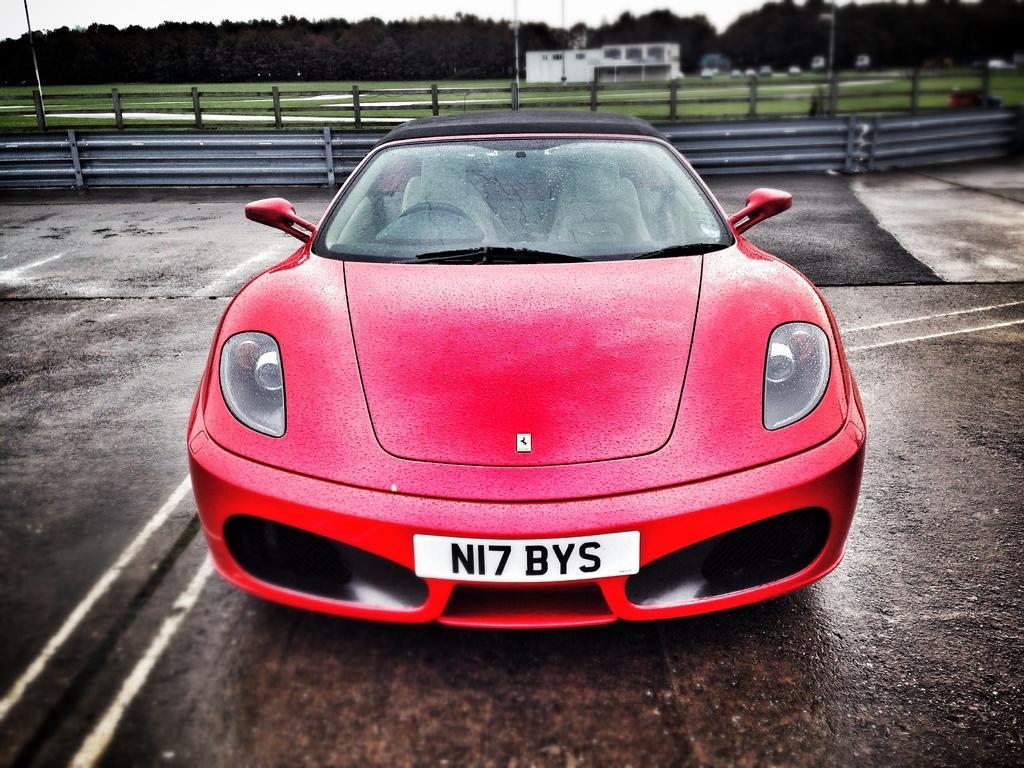How would you summarize this image in a sentence or two? In this picture we can see a car on the road. In the background we can see a fence, poles, house, vehicles, trees, and sky. 